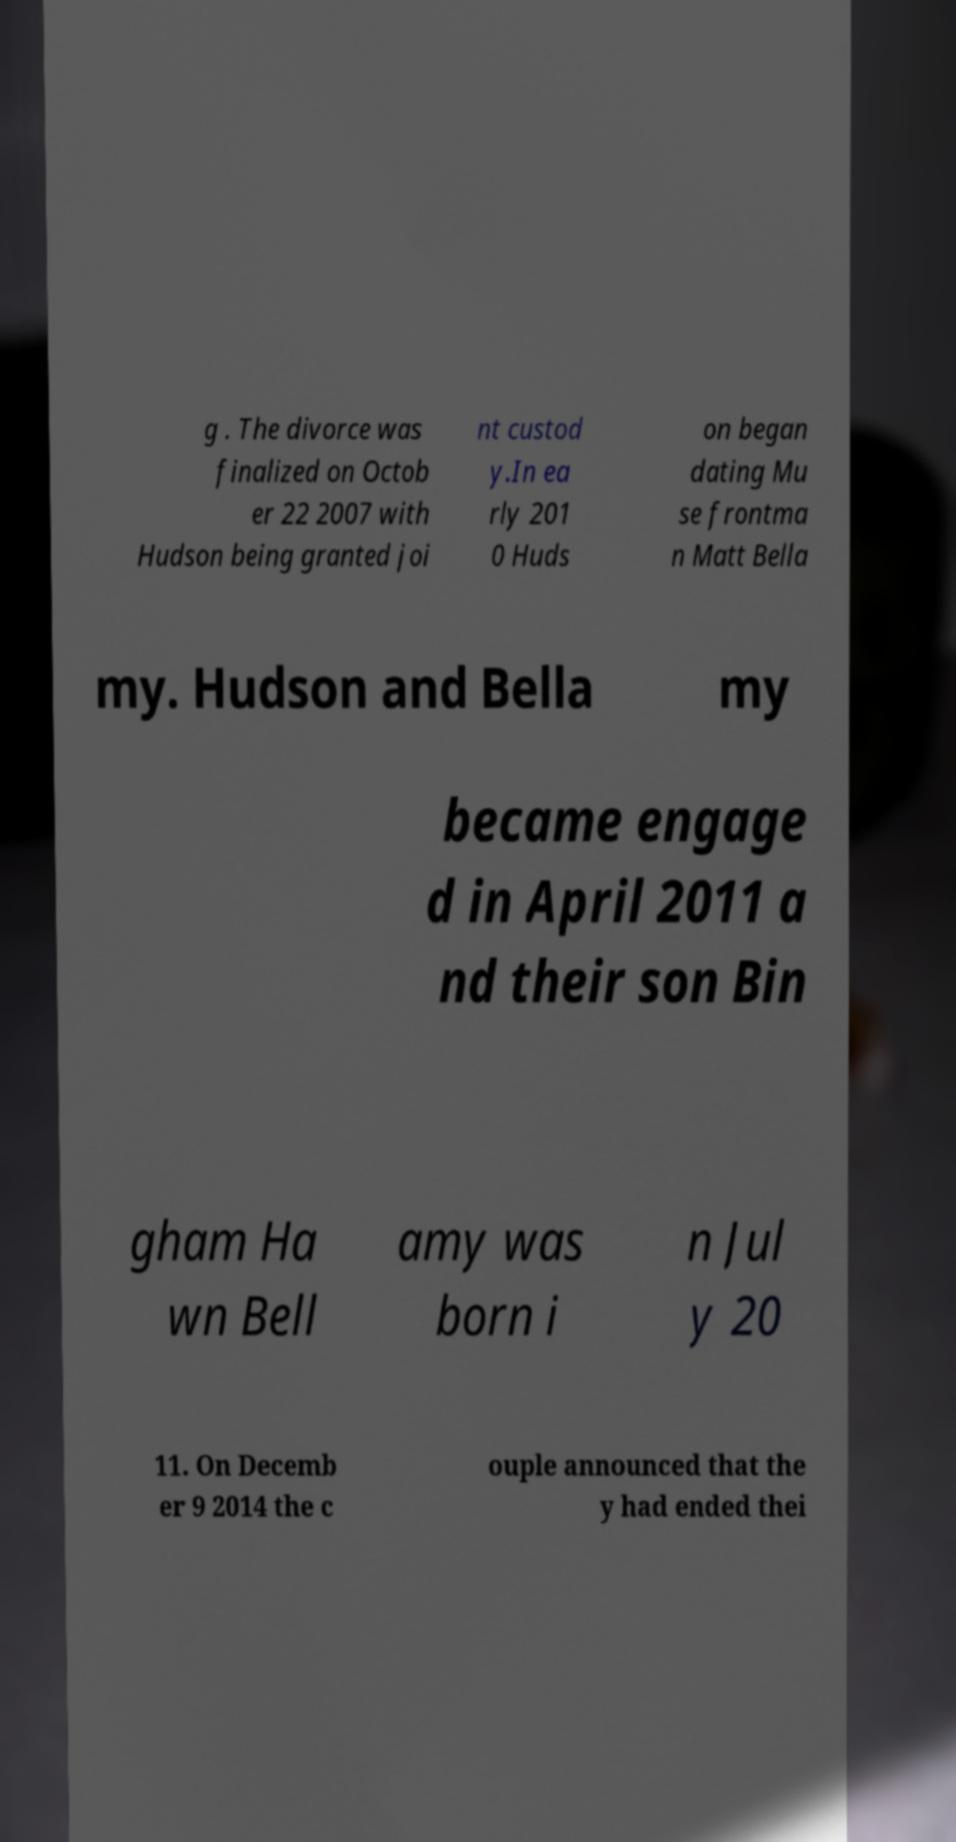What messages or text are displayed in this image? I need them in a readable, typed format. g . The divorce was finalized on Octob er 22 2007 with Hudson being granted joi nt custod y.In ea rly 201 0 Huds on began dating Mu se frontma n Matt Bella my. Hudson and Bella my became engage d in April 2011 a nd their son Bin gham Ha wn Bell amy was born i n Jul y 20 11. On Decemb er 9 2014 the c ouple announced that the y had ended thei 